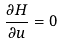Convert formula to latex. <formula><loc_0><loc_0><loc_500><loc_500>\frac { \partial H } { \partial u } = 0</formula> 